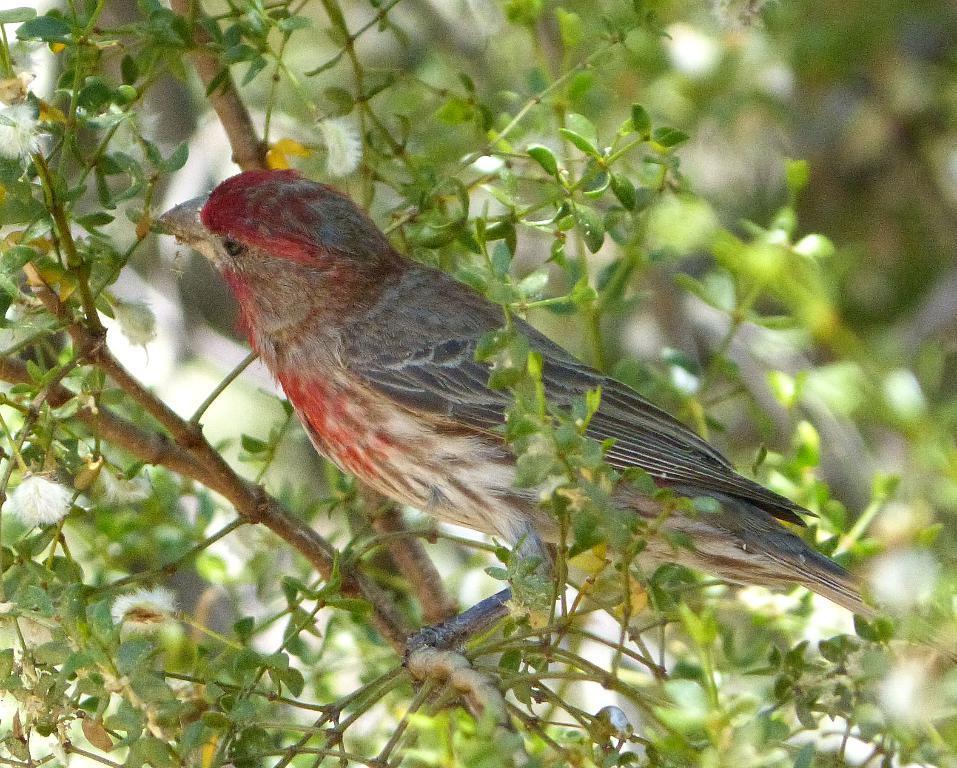In one or two sentences, can you explain what this image depicts? In this picture I can see there is a bird and there are a few stems around it with leaves and the backdrop of the image is blurred. 